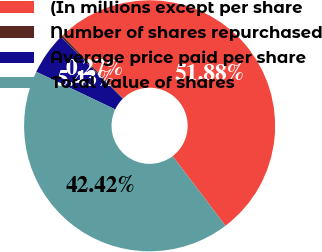Convert chart. <chart><loc_0><loc_0><loc_500><loc_500><pie_chart><fcel>(In millions except per share<fcel>Number of shares repurchased<fcel>Average price paid per share<fcel>Total value of shares<nl><fcel>51.88%<fcel>0.27%<fcel>5.43%<fcel>42.42%<nl></chart> 